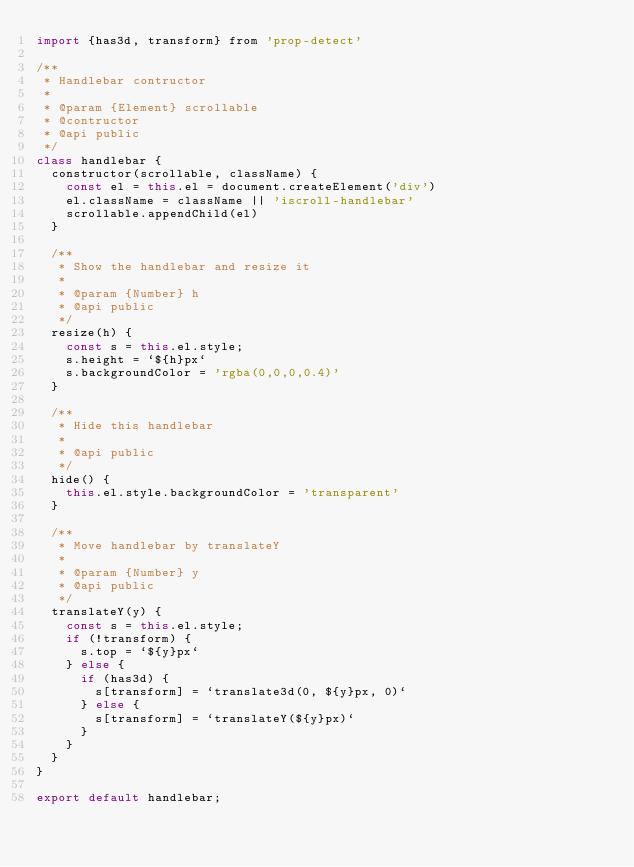Convert code to text. <code><loc_0><loc_0><loc_500><loc_500><_JavaScript_>import {has3d, transform} from 'prop-detect'

/**
 * Handlebar contructor
 *
 * @param {Element} scrollable
 * @contructor
 * @api public
 */
class handlebar {
  constructor(scrollable, className) {
    const el = this.el = document.createElement('div')
    el.className = className || 'iscroll-handlebar'
    scrollable.appendChild(el)
  }

  /**
   * Show the handlebar and resize it
   *
   * @param {Number} h
   * @api public
   */
  resize(h) {
    const s = this.el.style;
    s.height = `${h}px`
    s.backgroundColor = 'rgba(0,0,0,0.4)'
  }

  /**
   * Hide this handlebar
   *
   * @api public
   */
  hide() {
    this.el.style.backgroundColor = 'transparent'
  }

  /**
   * Move handlebar by translateY
   *
   * @param {Number} y
   * @api public
   */
  translateY(y) {
    const s = this.el.style;
    if (!transform) {
      s.top = `${y}px`
    } else {
      if (has3d) {
        s[transform] = `translate3d(0, ${y}px, 0)`
      } else {
        s[transform] = `translateY(${y}px)`
      }
    }
  }
}

export default handlebar;
</code> 